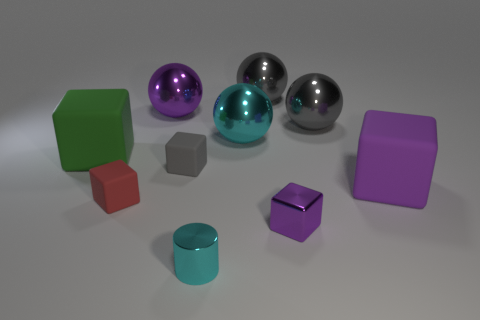Subtract all green cubes. How many cubes are left? 4 Subtract all gray cubes. How many cubes are left? 4 Subtract all brown cubes. Subtract all yellow balls. How many cubes are left? 5 Subtract all spheres. How many objects are left? 6 Add 7 big gray metal things. How many big gray metal things are left? 9 Add 2 large purple objects. How many large purple objects exist? 4 Subtract 0 green cylinders. How many objects are left? 10 Subtract all small gray blocks. Subtract all gray matte objects. How many objects are left? 8 